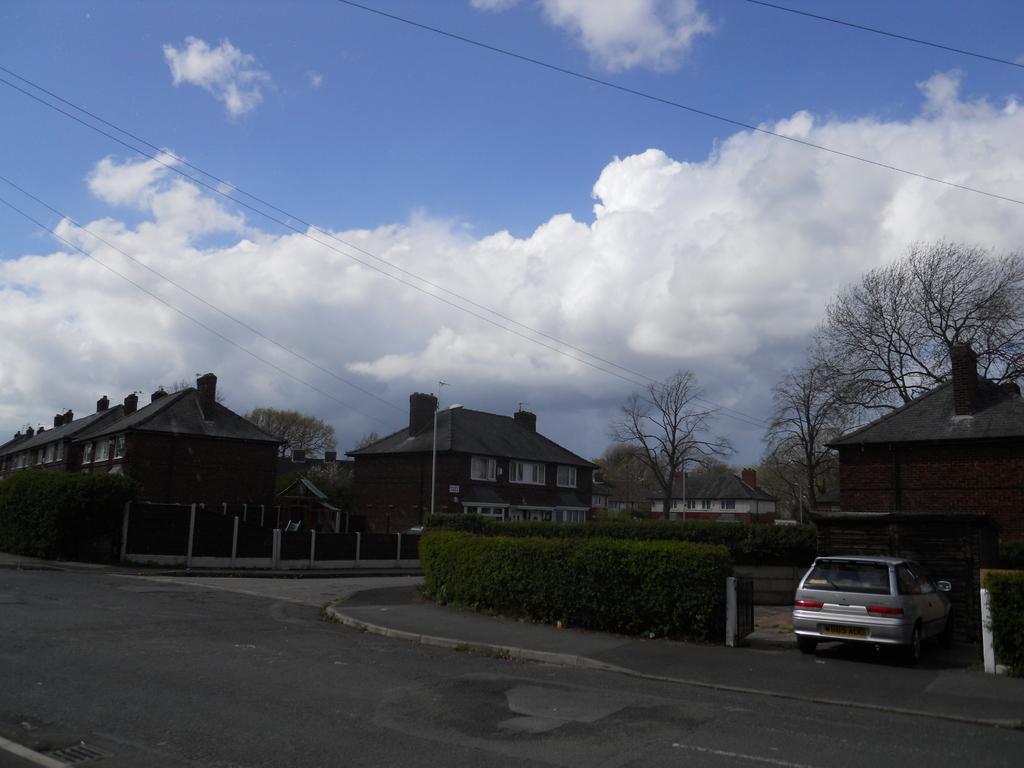Can you describe this image briefly? In the image we can see there are many buildings and these are the windows of the building and there is a vehicle. This is a road, plant, trees, electric wires and cloudy pale blue sky. 